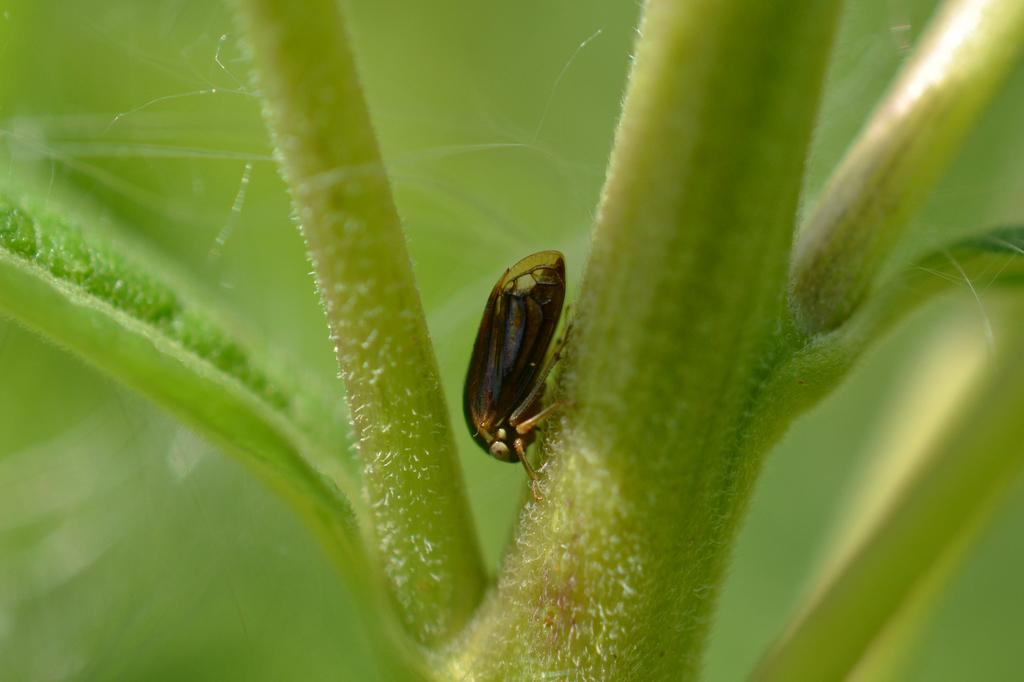What type of creature is present in the image? There is an insect in the image. Where is the insect located? The insect is on a plant. Can you describe the background of the image? The background of the image is blurred. What type of thread is being used to sew the patch onto the insect's wing in the image? There is no thread, patch, or sewing activity present in the image. The insect is simply on a plant, and the background is blurred. 